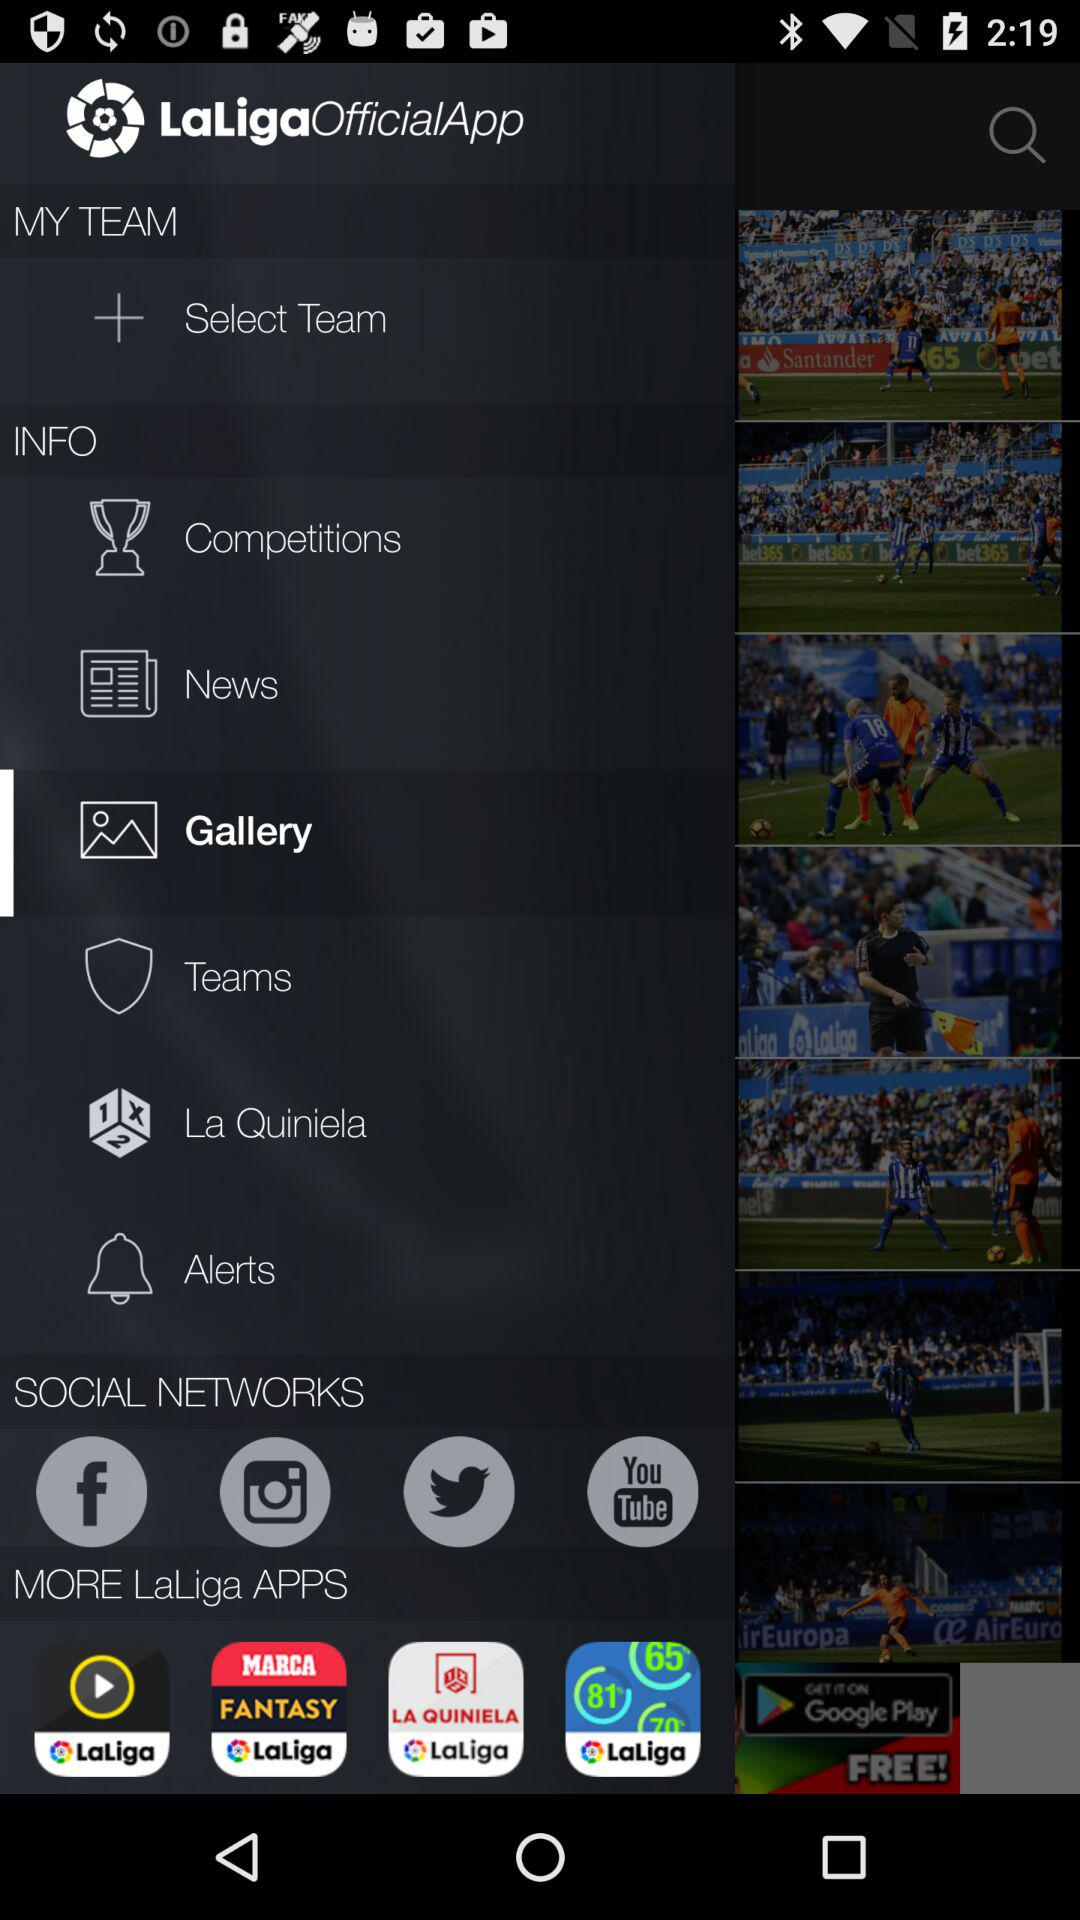What are the social networks given? The social networks given are "Facebook," "Instagram", "Twitter", and "Youtube". 